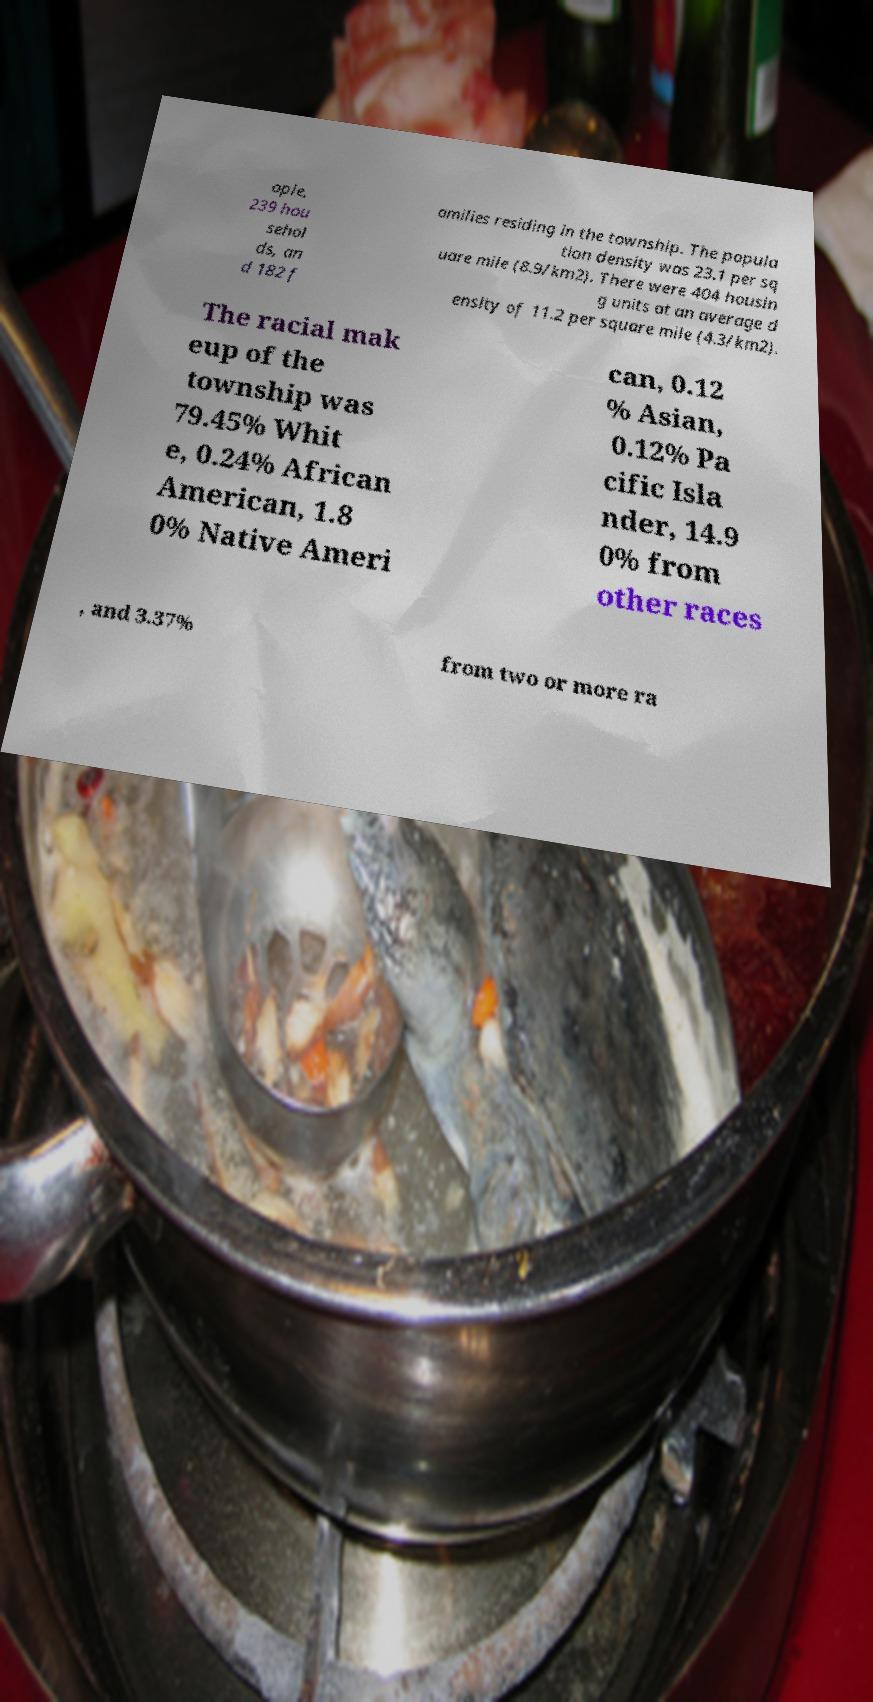Could you extract and type out the text from this image? ople, 239 hou sehol ds, an d 182 f amilies residing in the township. The popula tion density was 23.1 per sq uare mile (8.9/km2). There were 404 housin g units at an average d ensity of 11.2 per square mile (4.3/km2). The racial mak eup of the township was 79.45% Whit e, 0.24% African American, 1.8 0% Native Ameri can, 0.12 % Asian, 0.12% Pa cific Isla nder, 14.9 0% from other races , and 3.37% from two or more ra 